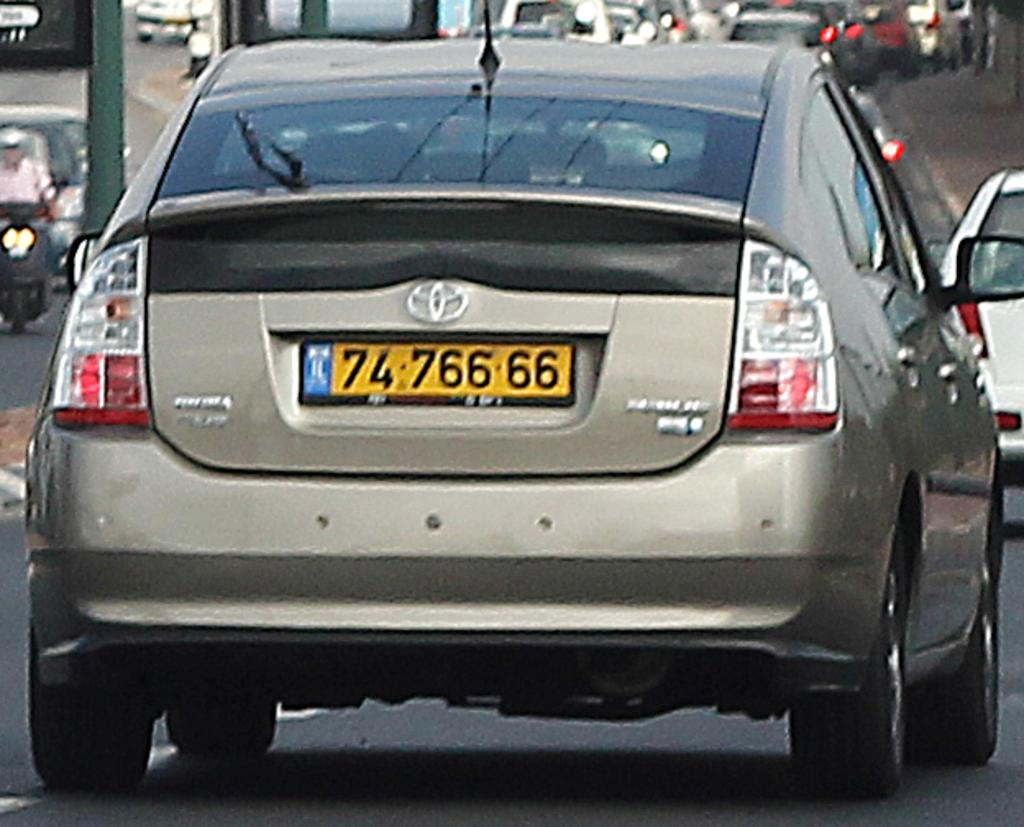Provide a one-sentence caption for the provided image. A tan Toyota Prius drives down the road. 